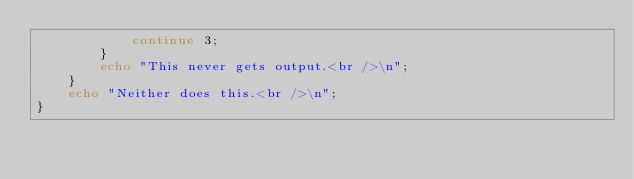<code> <loc_0><loc_0><loc_500><loc_500><_PHP_>            continue 3;
        }
        echo "This never gets output.<br />\n";
    }
    echo "Neither does this.<br />\n";
}</code> 